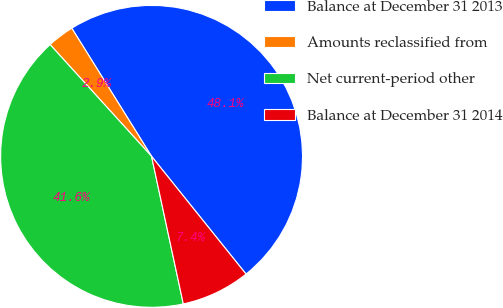Convert chart. <chart><loc_0><loc_0><loc_500><loc_500><pie_chart><fcel>Balance at December 31 2013<fcel>Amounts reclassified from<fcel>Net current-period other<fcel>Balance at December 31 2014<nl><fcel>48.1%<fcel>2.87%<fcel>41.64%<fcel>7.39%<nl></chart> 